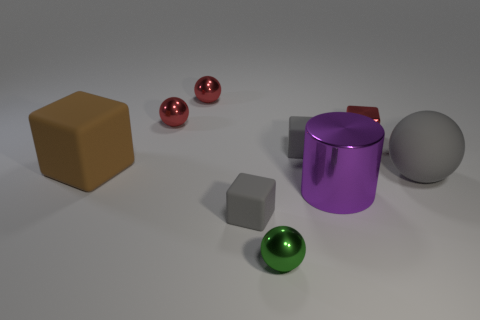Does the cylinder have the same color as the big sphere? no 